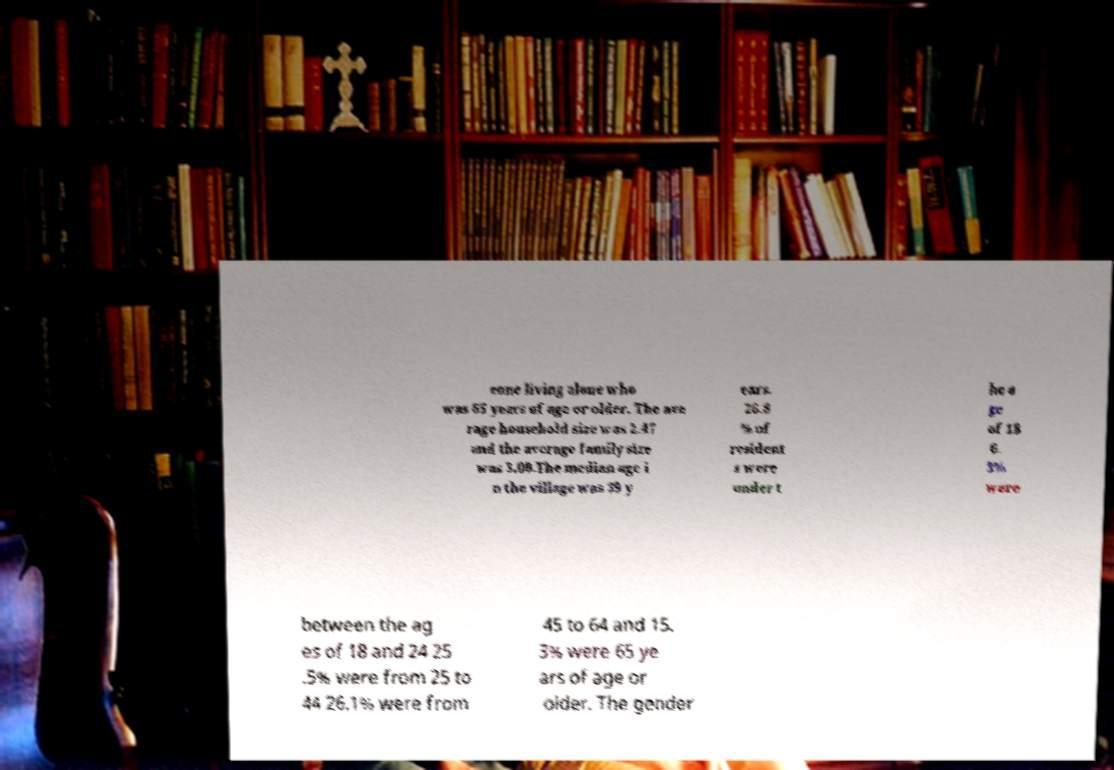Could you extract and type out the text from this image? eone living alone who was 65 years of age or older. The ave rage household size was 2.47 and the average family size was 3.00.The median age i n the village was 39 y ears. 26.8 % of resident s were under t he a ge of 18 6. 3% were between the ag es of 18 and 24 25 .5% were from 25 to 44 26.1% were from 45 to 64 and 15. 3% were 65 ye ars of age or older. The gender 